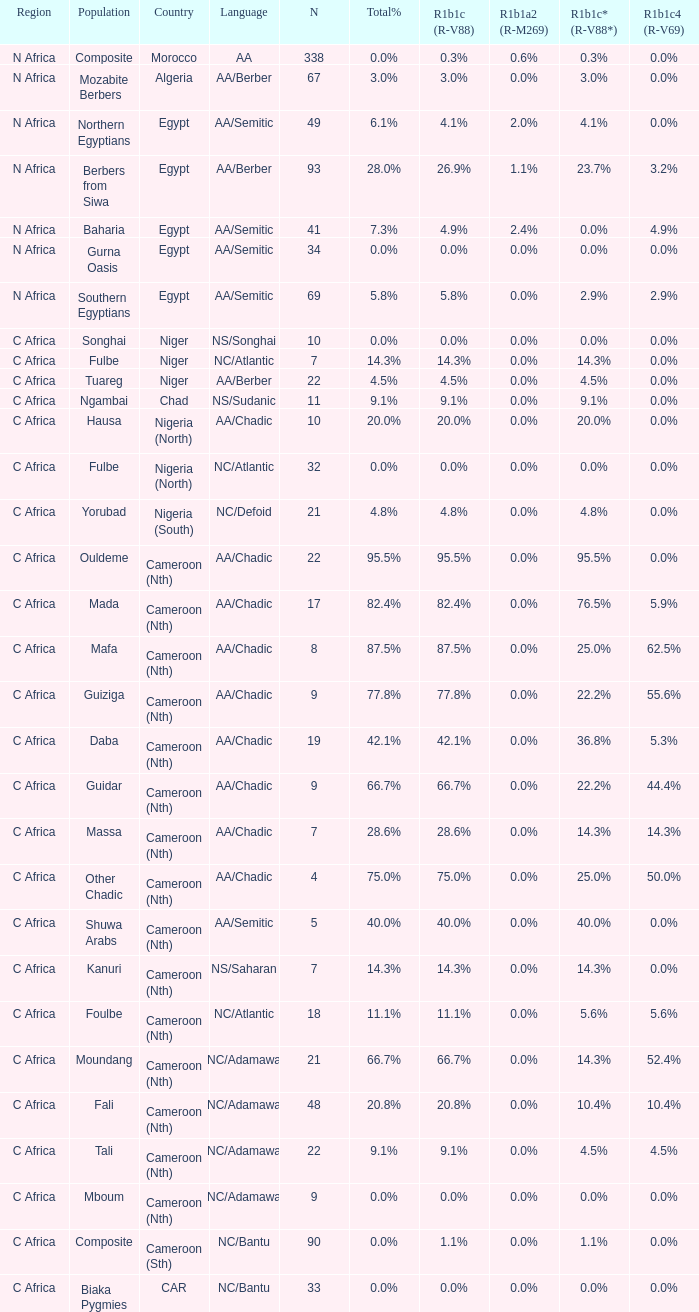How many n are documented for berbers from siwa? 1.0. 